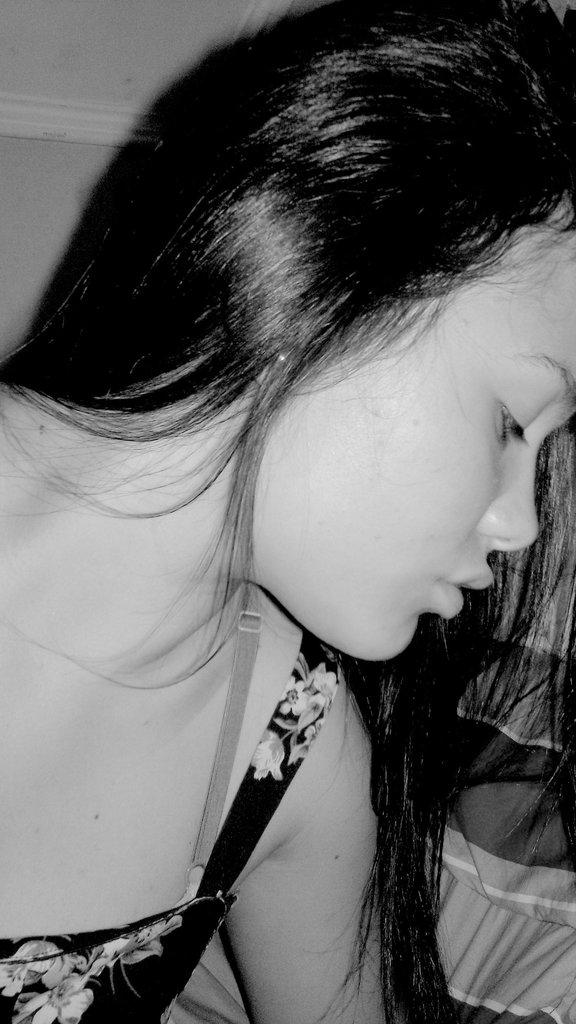What is the color scheme of the image? The image is black and white. Can you describe the woman in the image? There is a woman in the image, and she is wearing a black dress with floral print. What is the color of the woman's hair? The woman's hair color is black. Is the woman playing a guitar in the image? There is no guitar present in the image. What color is the paint on the wall behind the woman? The image is black and white, so it is not possible to determine the color of any paint on the wall. 